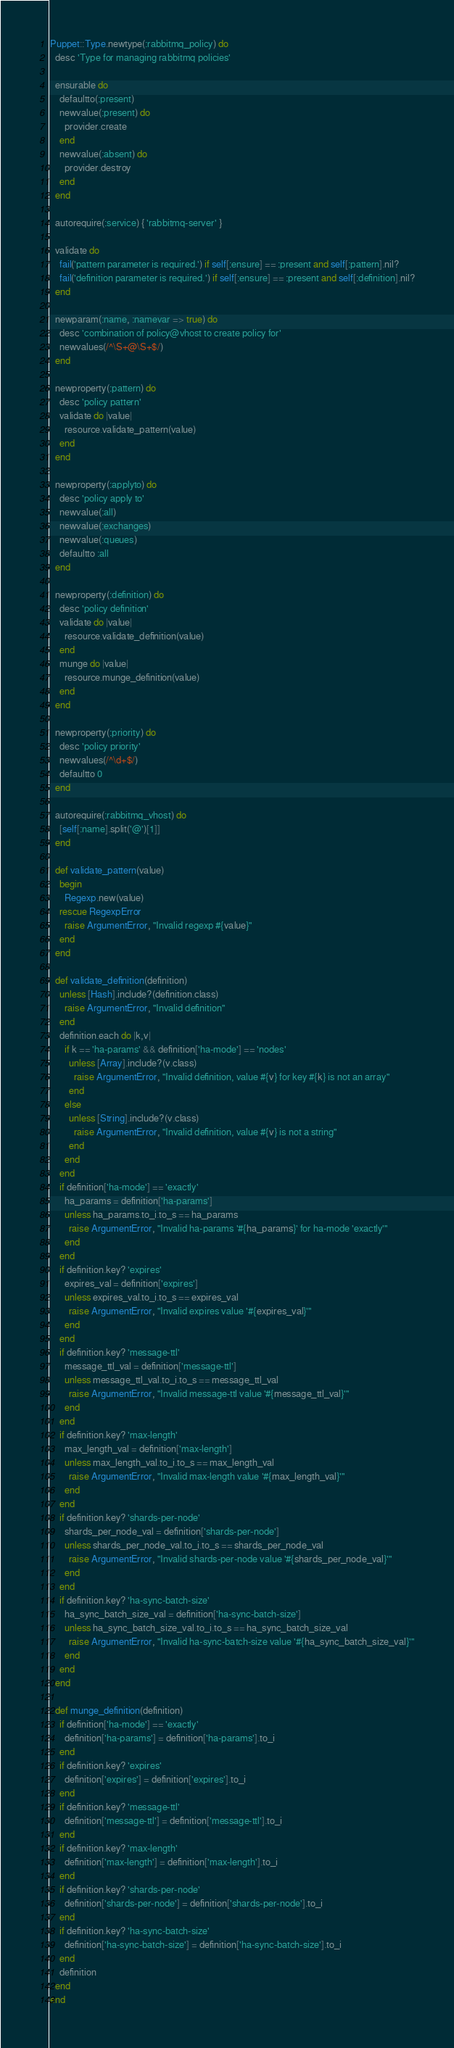<code> <loc_0><loc_0><loc_500><loc_500><_Ruby_>Puppet::Type.newtype(:rabbitmq_policy) do
  desc 'Type for managing rabbitmq policies'

  ensurable do
    defaultto(:present)
    newvalue(:present) do
      provider.create
    end
    newvalue(:absent) do
      provider.destroy
    end
  end

  autorequire(:service) { 'rabbitmq-server' }

  validate do
    fail('pattern parameter is required.') if self[:ensure] == :present and self[:pattern].nil?
    fail('definition parameter is required.') if self[:ensure] == :present and self[:definition].nil?
  end

  newparam(:name, :namevar => true) do
    desc 'combination of policy@vhost to create policy for'
    newvalues(/^\S+@\S+$/)
  end

  newproperty(:pattern) do
    desc 'policy pattern'
    validate do |value|
      resource.validate_pattern(value)
    end
  end

  newproperty(:applyto) do
    desc 'policy apply to'
    newvalue(:all)
    newvalue(:exchanges)
    newvalue(:queues)
    defaultto :all
  end

  newproperty(:definition) do
    desc 'policy definition'
    validate do |value|
      resource.validate_definition(value)
    end
    munge do |value|
      resource.munge_definition(value)
    end
  end

  newproperty(:priority) do
    desc 'policy priority'
    newvalues(/^\d+$/)
    defaultto 0
  end

  autorequire(:rabbitmq_vhost) do
    [self[:name].split('@')[1]]
  end

  def validate_pattern(value)
    begin
      Regexp.new(value)
    rescue RegexpError
      raise ArgumentError, "Invalid regexp #{value}"
    end
  end

  def validate_definition(definition)
    unless [Hash].include?(definition.class)
      raise ArgumentError, "Invalid definition"
    end
    definition.each do |k,v|
      if k == 'ha-params' && definition['ha-mode'] == 'nodes'
        unless [Array].include?(v.class)
          raise ArgumentError, "Invalid definition, value #{v} for key #{k} is not an array"
        end
      else
        unless [String].include?(v.class)
          raise ArgumentError, "Invalid definition, value #{v} is not a string"
        end
      end
    end
    if definition['ha-mode'] == 'exactly'
      ha_params = definition['ha-params']
      unless ha_params.to_i.to_s == ha_params
        raise ArgumentError, "Invalid ha-params '#{ha_params}' for ha-mode 'exactly'"
      end
    end
    if definition.key? 'expires'
      expires_val = definition['expires']
      unless expires_val.to_i.to_s == expires_val
        raise ArgumentError, "Invalid expires value '#{expires_val}'"
      end
    end
    if definition.key? 'message-ttl'
      message_ttl_val = definition['message-ttl']
      unless message_ttl_val.to_i.to_s == message_ttl_val
        raise ArgumentError, "Invalid message-ttl value '#{message_ttl_val}'"
      end
    end
    if definition.key? 'max-length'
      max_length_val = definition['max-length']
      unless max_length_val.to_i.to_s == max_length_val
        raise ArgumentError, "Invalid max-length value '#{max_length_val}'"
      end
    end
    if definition.key? 'shards-per-node'
      shards_per_node_val = definition['shards-per-node']
      unless shards_per_node_val.to_i.to_s == shards_per_node_val
        raise ArgumentError, "Invalid shards-per-node value '#{shards_per_node_val}'"
      end
    end
    if definition.key? 'ha-sync-batch-size'
      ha_sync_batch_size_val = definition['ha-sync-batch-size']
      unless ha_sync_batch_size_val.to_i.to_s == ha_sync_batch_size_val
        raise ArgumentError, "Invalid ha-sync-batch-size value '#{ha_sync_batch_size_val}'"
      end
    end
  end

  def munge_definition(definition)
    if definition['ha-mode'] == 'exactly'
      definition['ha-params'] = definition['ha-params'].to_i
    end
    if definition.key? 'expires'
      definition['expires'] = definition['expires'].to_i
    end
    if definition.key? 'message-ttl'
      definition['message-ttl'] = definition['message-ttl'].to_i
    end
    if definition.key? 'max-length'
      definition['max-length'] = definition['max-length'].to_i
    end
    if definition.key? 'shards-per-node'
      definition['shards-per-node'] = definition['shards-per-node'].to_i
    end
    if definition.key? 'ha-sync-batch-size'
      definition['ha-sync-batch-size'] = definition['ha-sync-batch-size'].to_i
    end
    definition
  end
end
</code> 